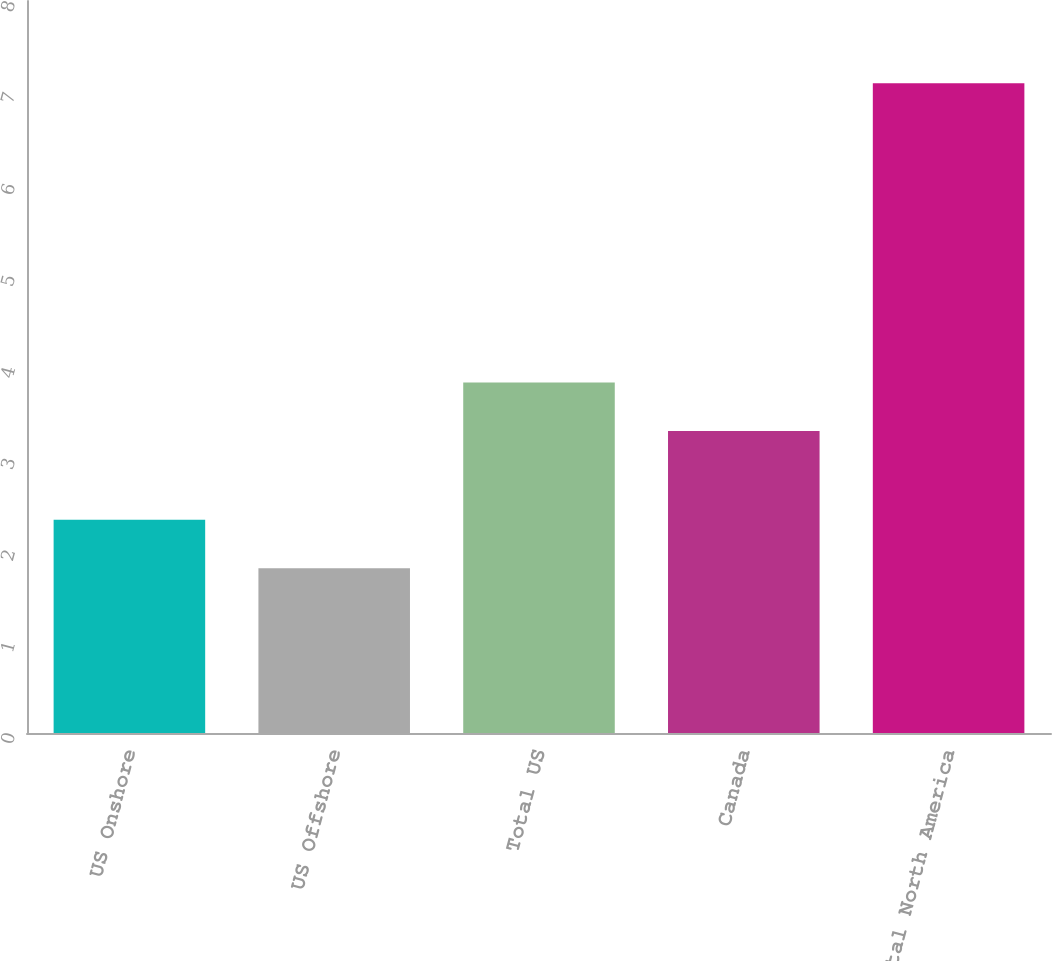<chart> <loc_0><loc_0><loc_500><loc_500><bar_chart><fcel>US Onshore<fcel>US Offshore<fcel>Total US<fcel>Canada<fcel>Total North America<nl><fcel>2.33<fcel>1.8<fcel>3.83<fcel>3.3<fcel>7.1<nl></chart> 